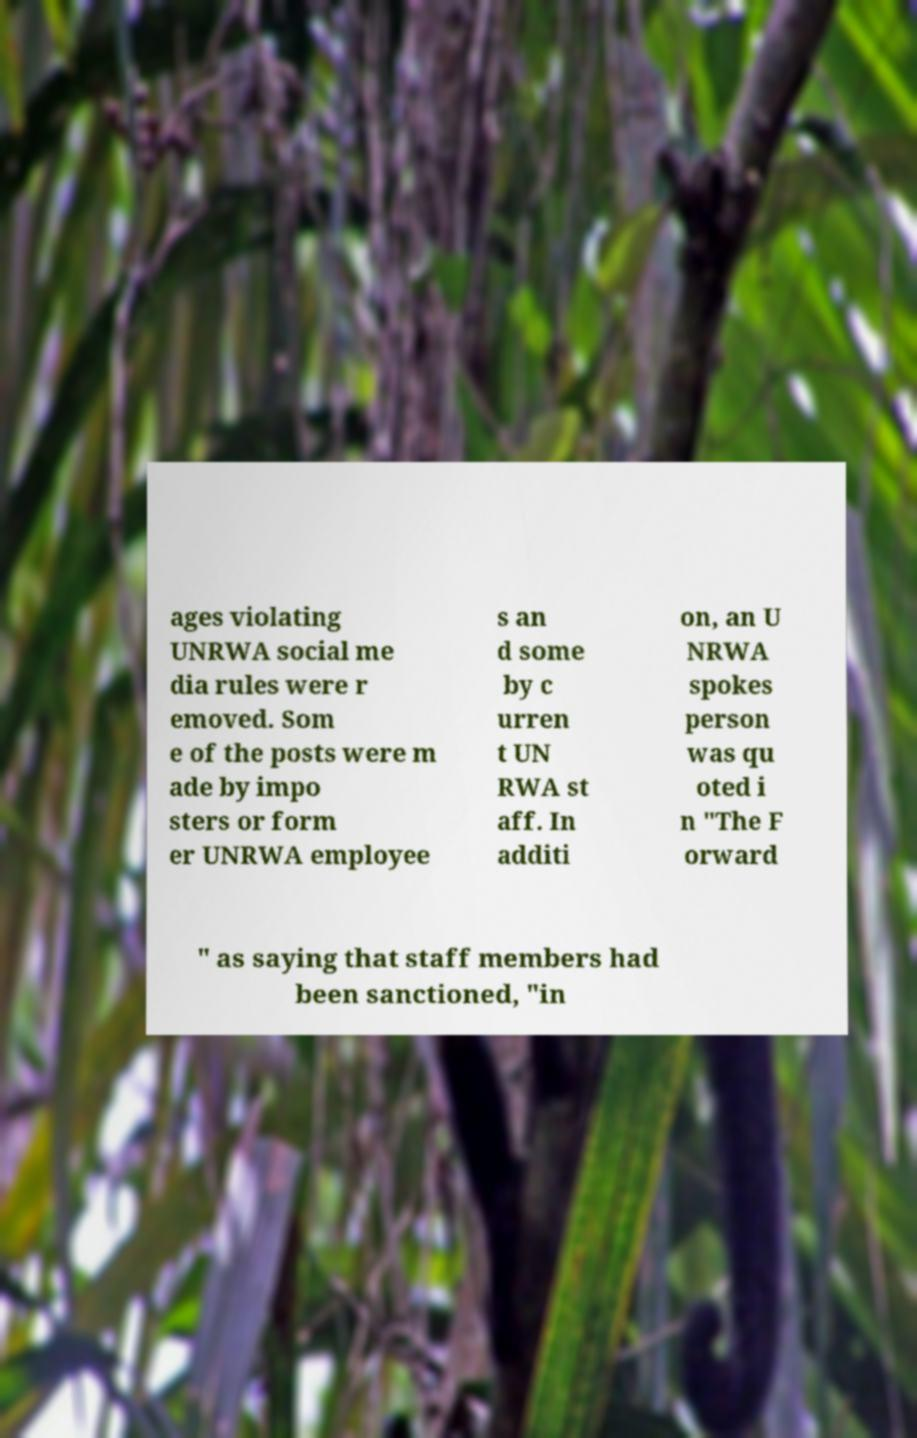Can you read and provide the text displayed in the image?This photo seems to have some interesting text. Can you extract and type it out for me? ages violating UNRWA social me dia rules were r emoved. Som e of the posts were m ade by impo sters or form er UNRWA employee s an d some by c urren t UN RWA st aff. In additi on, an U NRWA spokes person was qu oted i n "The F orward " as saying that staff members had been sanctioned, "in 